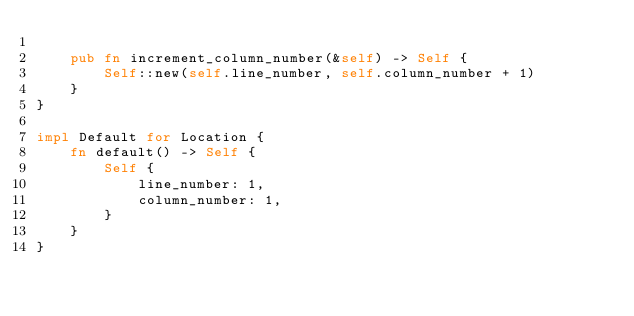Convert code to text. <code><loc_0><loc_0><loc_500><loc_500><_Rust_>
    pub fn increment_column_number(&self) -> Self {
        Self::new(self.line_number, self.column_number + 1)
    }
}

impl Default for Location {
    fn default() -> Self {
        Self {
            line_number: 1,
            column_number: 1,
        }
    }
}
</code> 